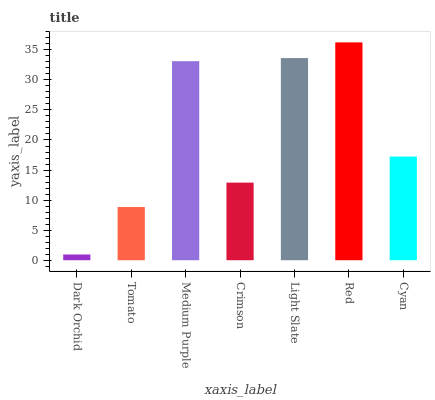Is Dark Orchid the minimum?
Answer yes or no. Yes. Is Red the maximum?
Answer yes or no. Yes. Is Tomato the minimum?
Answer yes or no. No. Is Tomato the maximum?
Answer yes or no. No. Is Tomato greater than Dark Orchid?
Answer yes or no. Yes. Is Dark Orchid less than Tomato?
Answer yes or no. Yes. Is Dark Orchid greater than Tomato?
Answer yes or no. No. Is Tomato less than Dark Orchid?
Answer yes or no. No. Is Cyan the high median?
Answer yes or no. Yes. Is Cyan the low median?
Answer yes or no. Yes. Is Medium Purple the high median?
Answer yes or no. No. Is Medium Purple the low median?
Answer yes or no. No. 